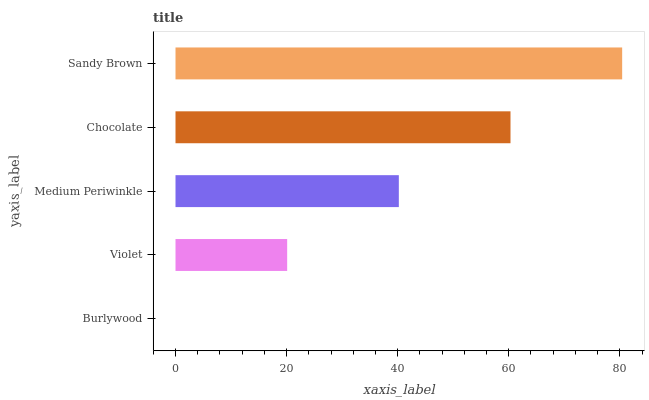Is Burlywood the minimum?
Answer yes or no. Yes. Is Sandy Brown the maximum?
Answer yes or no. Yes. Is Violet the minimum?
Answer yes or no. No. Is Violet the maximum?
Answer yes or no. No. Is Violet greater than Burlywood?
Answer yes or no. Yes. Is Burlywood less than Violet?
Answer yes or no. Yes. Is Burlywood greater than Violet?
Answer yes or no. No. Is Violet less than Burlywood?
Answer yes or no. No. Is Medium Periwinkle the high median?
Answer yes or no. Yes. Is Medium Periwinkle the low median?
Answer yes or no. Yes. Is Sandy Brown the high median?
Answer yes or no. No. Is Chocolate the low median?
Answer yes or no. No. 